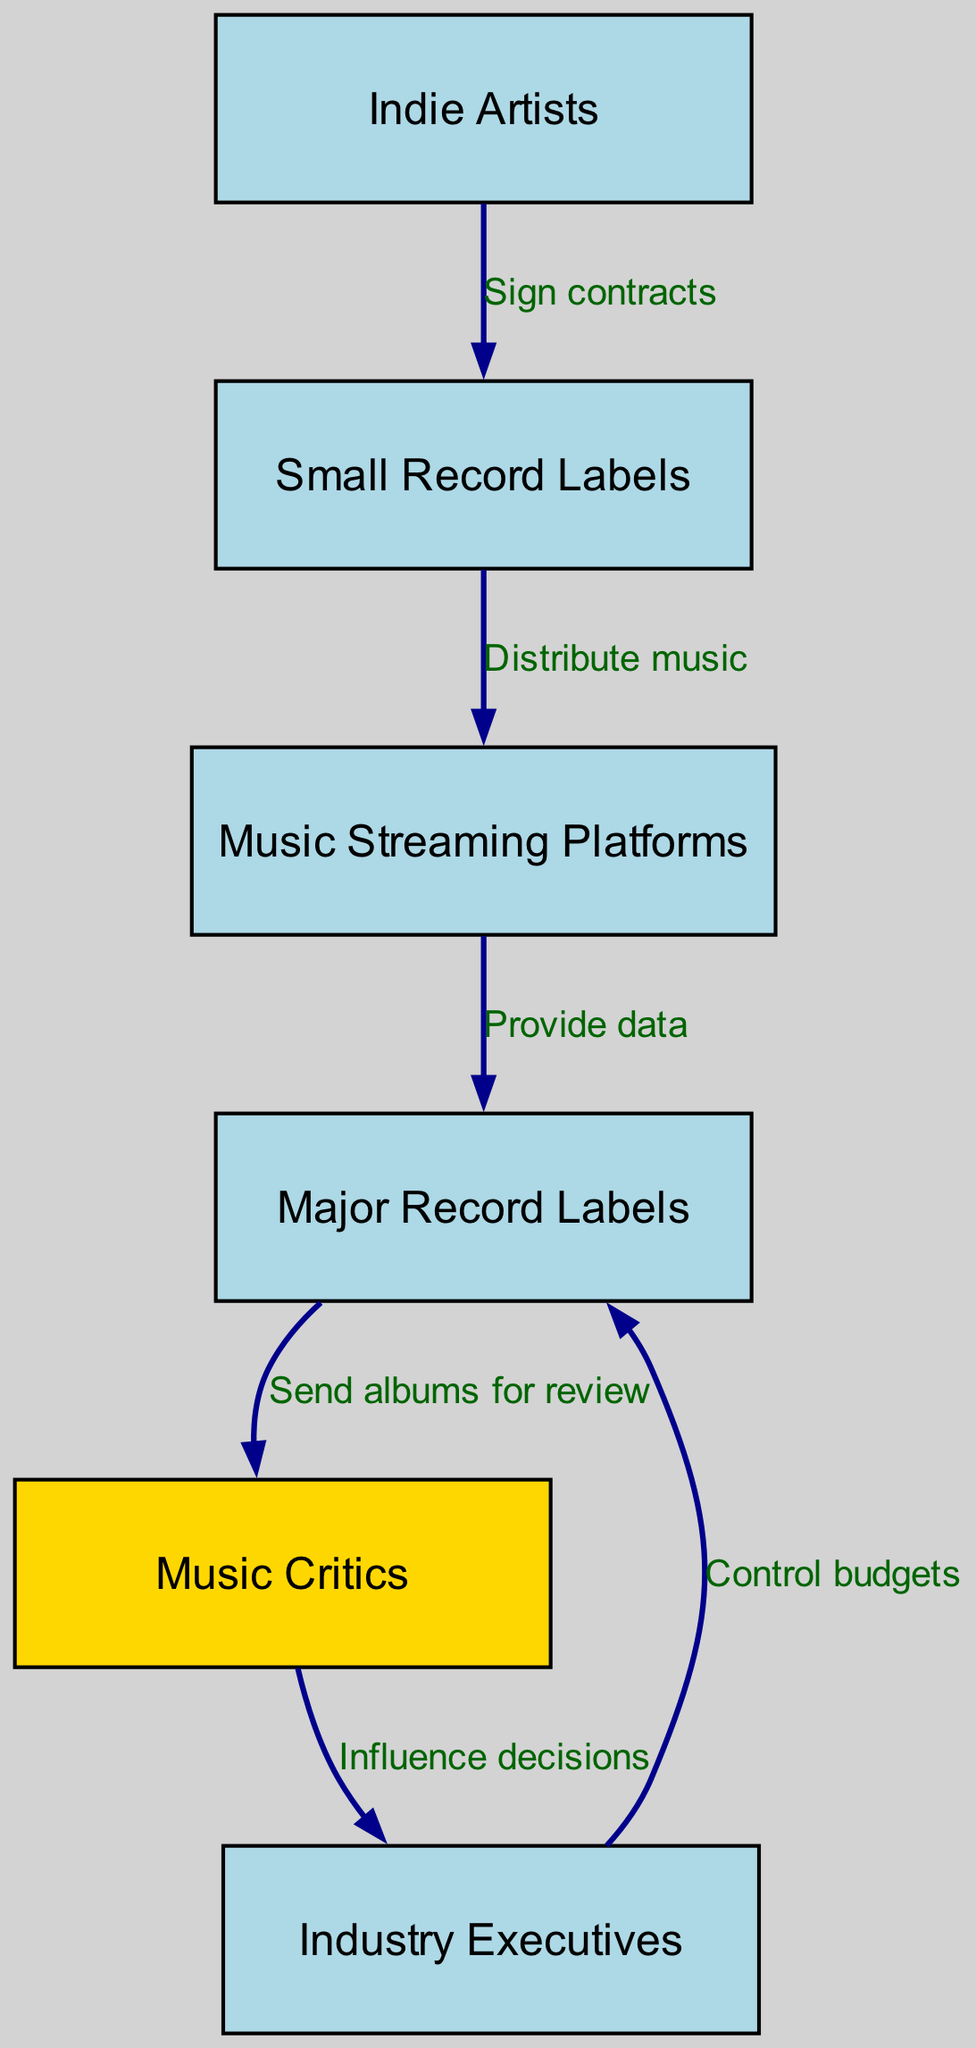What are the nodes in the diagram? The nodes in the diagram represent different entities in the music industry food chain, which are Indie Artists, Small Record Labels, Music Streaming Platforms, Major Record Labels, Music Critics, and Industry Executives.
Answer: Indie Artists, Small Record Labels, Music Streaming Platforms, Major Record Labels, Music Critics, Industry Executives How many edges are there? The edges in the diagram represent the relationships between the nodes, and there are a total of 6 edges connecting the different entities.
Answer: 6 What relationship connects Indie Artists and Small Record Labels? The relationship between Indie Artists and Small Record Labels indicates that Indie Artists sign contracts with Small Record Labels, which is the action that establishes their connection in the food chain.
Answer: Sign contracts Which node does the edge from Music Critics lead to? The edge from Music Critics leads to Industry Executives, indicating that Music Critics influence decisions made by Industry Executives.
Answer: Industry Executives What do Major Record Labels control? Major Record Labels control budgets, which is indicated by the edge from Industry Executives to Major Record Labels highlighting their managerial authority in the financial aspects of the music industry.
Answer: Budgets Which node is highlighted in gold? The node highlighted in gold in the diagram is Music Critics, indicating their significant role and possibly their impact within the music industry food chain.
Answer: Music Critics Which nodes are involved in the distribution of music? The nodes involved in the distribution of music are Small Record Labels and Music Streaming Platforms, with Small Record Labels distributing music through Music Streaming Platforms as part of their function in the industry.
Answer: Small Record Labels, Music Streaming Platforms What action do Industry Executives take based on influence? Industry Executives take decisions influenced by Music Critics, as indicated by the edge that connects these two nodes, meaning that the opinions of Music Critics can sway the choices made by Industry Executives.
Answer: Decisions What do Music Streaming Platforms provide to Major Record Labels? Music Streaming Platforms provide data to Major Record Labels, indicating that they supply valuable metrics and insights that help inform the strategies of Major Record Labels in the industry.
Answer: Data 